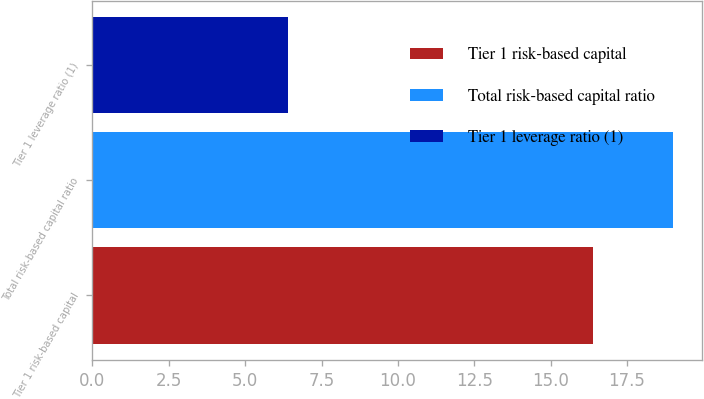Convert chart to OTSL. <chart><loc_0><loc_0><loc_500><loc_500><bar_chart><fcel>Tier 1 risk-based capital<fcel>Total risk-based capital ratio<fcel>Tier 1 leverage ratio (1)<nl><fcel>16.4<fcel>19<fcel>6.4<nl></chart> 